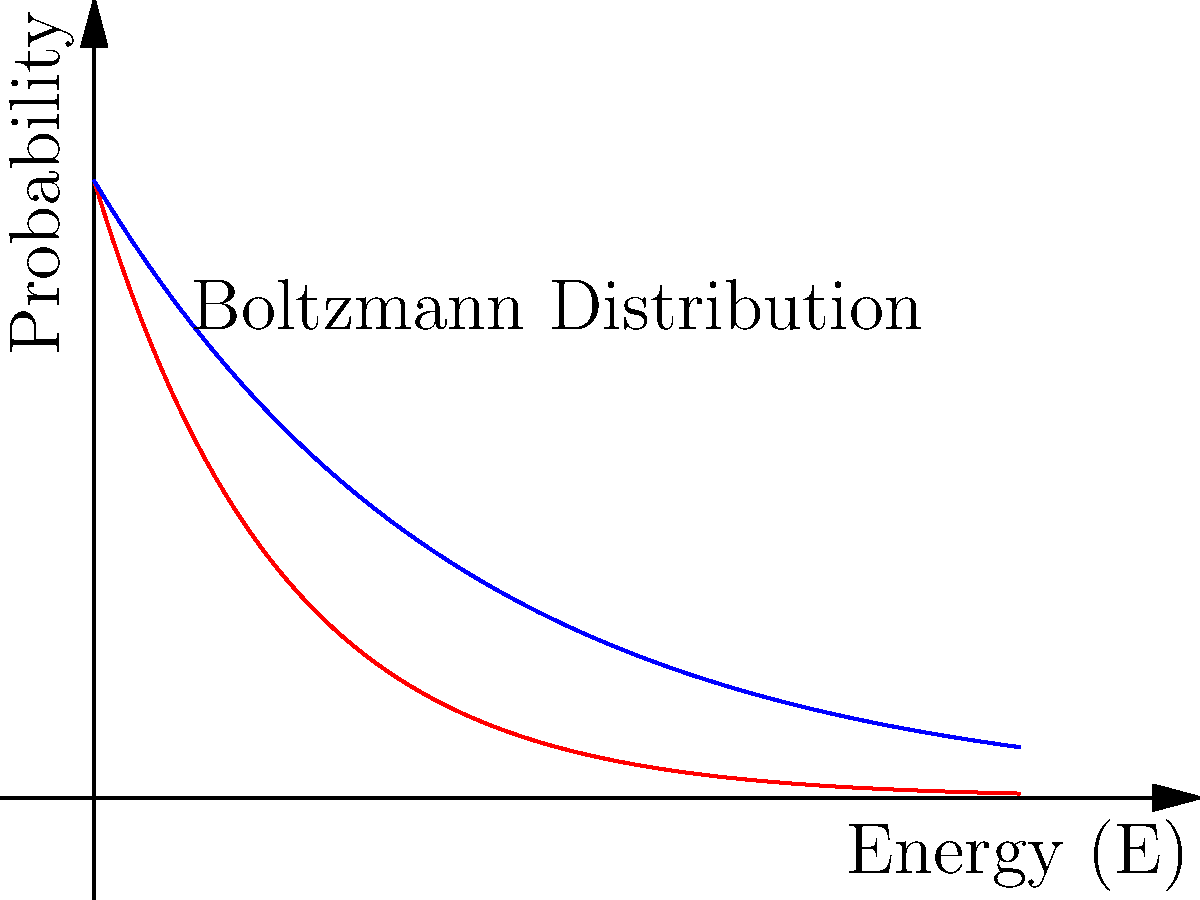In the context of feature selection for AI algorithms, consider the Boltzmann distribution applied to a set of features with different energies. The graph shows two probability curves for temperatures $T=2$ and $T=4$. How does increasing the temperature affect the probability distribution of selecting high-energy features, and what implications does this have for exploration vs. exploitation in AI algorithms? To answer this question, let's analyze the Boltzmann distribution and its application to feature selection in AI:

1. The Boltzmann distribution is given by:
   $$P(E) \propto e^{-E/kT}$$
   where $E$ is the energy, $T$ is the temperature, and $k$ is the Boltzmann constant.

2. In the context of feature selection, we can interpret:
   - Energy (E) as the cost or complexity of a feature
   - Temperature (T) as a control parameter for exploration

3. Observing the graph:
   - The red curve represents T=2
   - The blue curve represents T=4

4. As temperature increases (from T=2 to T=4):
   - The curve becomes flatter
   - The probability of selecting high-energy features increases

5. This flattening effect means:
   - At lower temperatures, low-energy (simpler) features are strongly preferred
   - At higher temperatures, the distribution becomes more uniform, giving higher-energy (more complex) features a better chance of being selected

6. Implications for AI algorithms:
   - Lower T: Exploitation - Focus on known, simple features
   - Higher T: Exploration - More likely to consider complex or novel features

7. In practice:
   - Starting with high T allows for broad exploration of the feature space
   - Gradually lowering T (simulated annealing) can help find an optimal balance between simple and complex features
Answer: Increasing temperature flattens the distribution, increasing the probability of selecting high-energy features, which promotes exploration over exploitation in AI algorithms. 